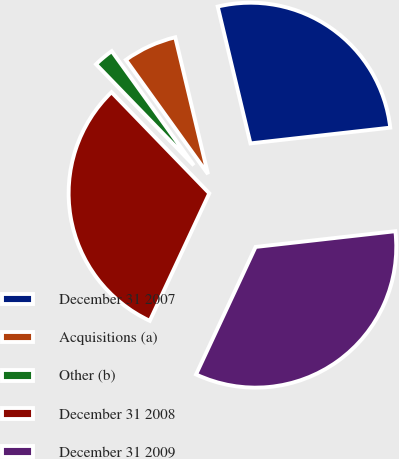<chart> <loc_0><loc_0><loc_500><loc_500><pie_chart><fcel>December 31 2007<fcel>Acquisitions (a)<fcel>Other (b)<fcel>December 31 2008<fcel>December 31 2009<nl><fcel>26.95%<fcel>6.18%<fcel>2.32%<fcel>30.81%<fcel>33.74%<nl></chart> 